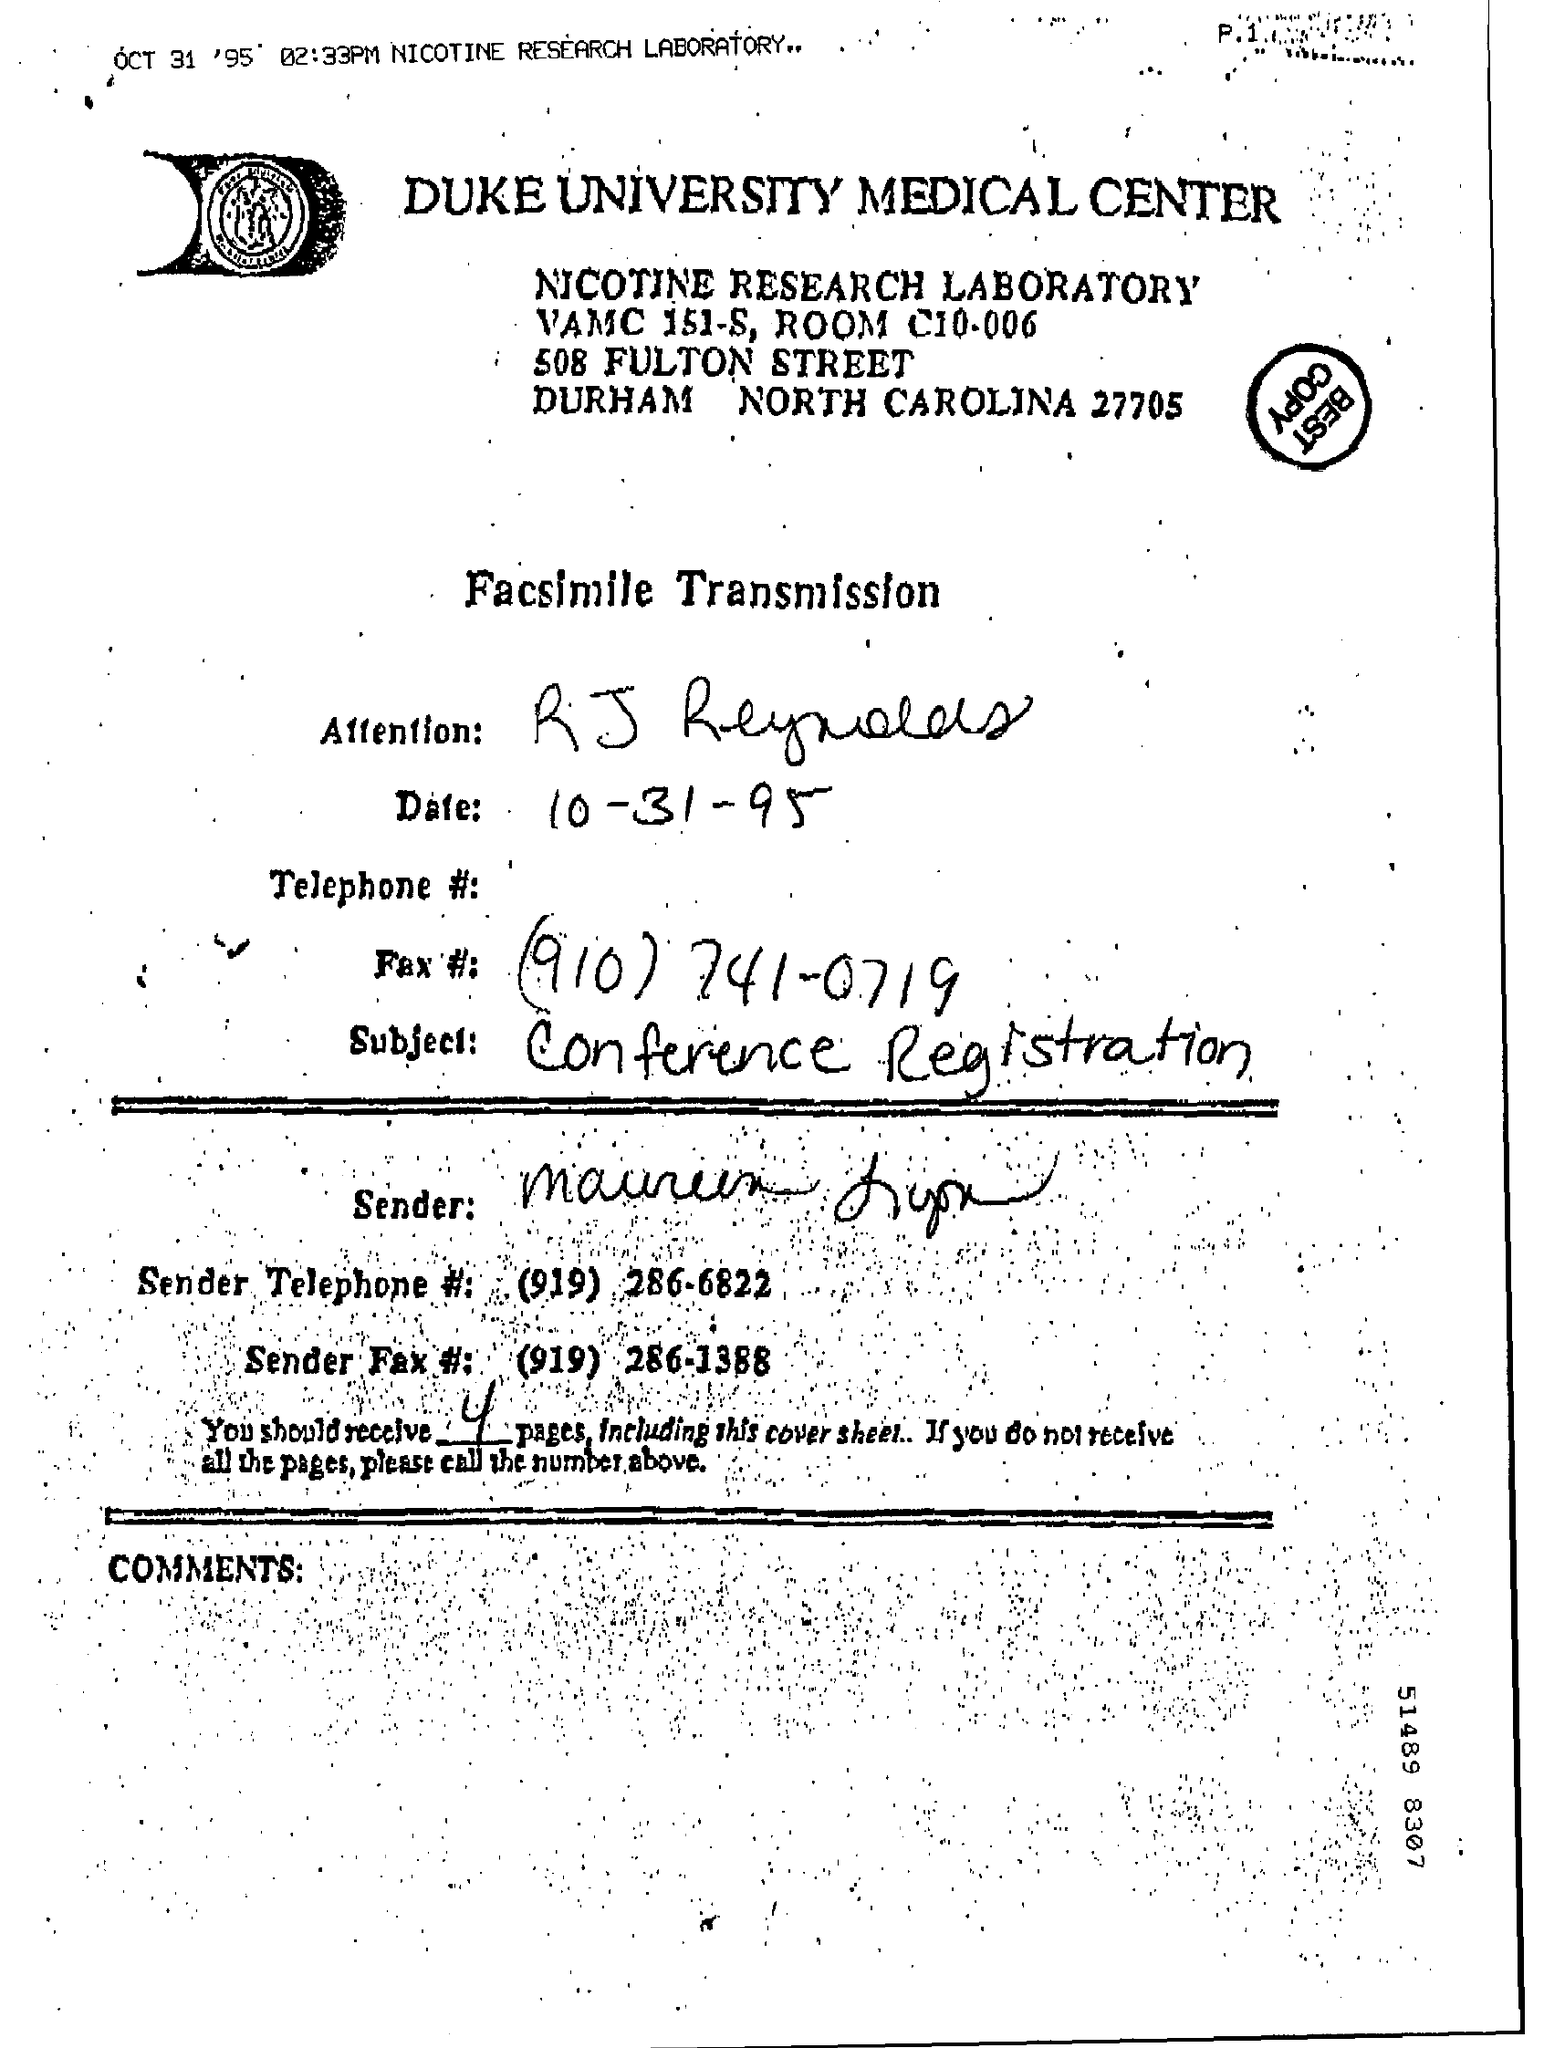Identify some key points in this picture. The subject of the facsimile transmission is conference registration. Four pages were sent. The facsimile date is October 31, 1995. 